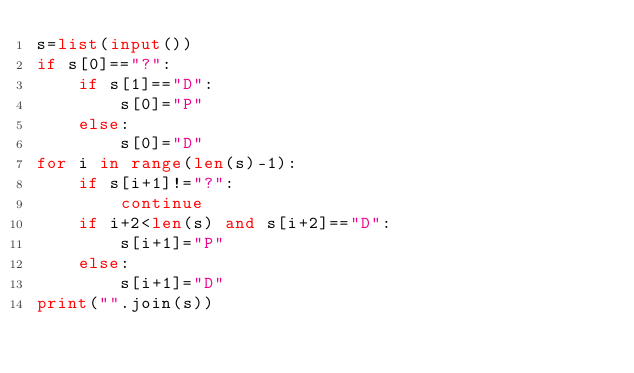Convert code to text. <code><loc_0><loc_0><loc_500><loc_500><_Python_>s=list(input())
if s[0]=="?":
    if s[1]=="D":
        s[0]="P"
    else:
        s[0]="D"
for i in range(len(s)-1):
    if s[i+1]!="?":
        continue
    if i+2<len(s) and s[i+2]=="D":
        s[i+1]="P"
    else:
        s[i+1]="D"
print("".join(s))</code> 